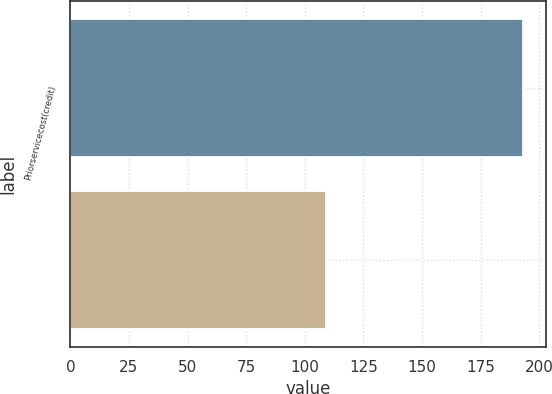Convert chart to OTSL. <chart><loc_0><loc_0><loc_500><loc_500><bar_chart><fcel>Priorservicecost(credit)<fcel>Unnamed: 1<nl><fcel>193<fcel>109<nl></chart> 